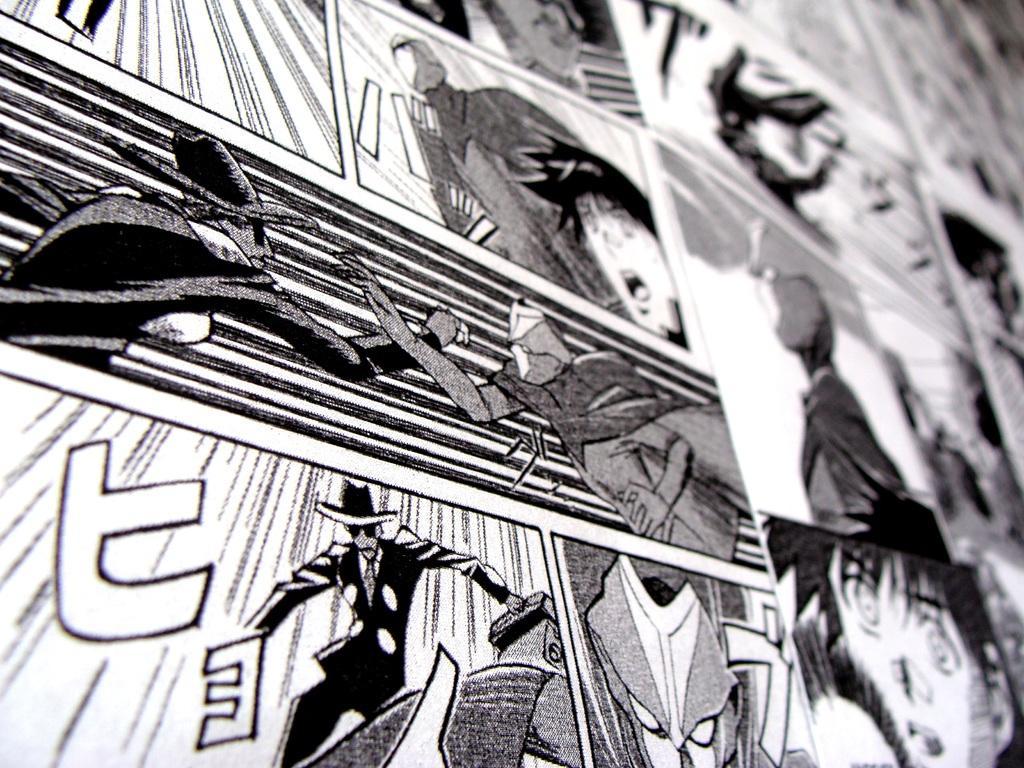Describe this image in one or two sentences. In this image we can see the black and white picture of an animation. 